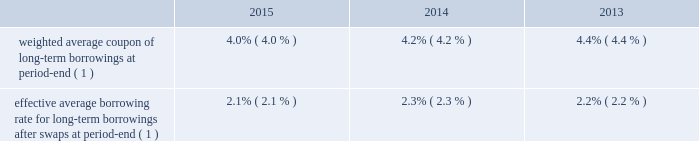Morgan stanley notes to consolidated financial statements 2014 ( continued ) senior debt securities often are denominated in various non-u.s .
Dollar currencies and may be structured to provide a return that is equity-linked , credit-linked , commodity-linked or linked to some other index ( e.g. , the consumer price index ) .
Senior debt also may be structured to be callable by the company or extendible at the option of holders of the senior debt securities .
Debt containing provisions that effectively allow the holders to put or extend the notes aggregated $ 2902 million at december 31 , 2015 and $ 2175 million at december 31 , 2014 .
In addition , in certain circumstances , certain purchasers may be entitled to cause the repurchase of the notes .
The aggregated value of notes subject to these arrangements was $ 650 million at december 31 , 2015 and $ 551 million at december 31 , 2014 .
Subordinated debt and junior subordinated debentures generally are issued to meet the capital requirements of the company or its regulated subsidiaries and primarily are u.s .
Dollar denominated .
During 2015 , morgan stanley capital trusts vi and vii redeemed all of their issued and outstanding 6.60% ( 6.60 % ) capital securities , respectively , and the company concurrently redeemed the related underlying junior subordinated debentures .
Senior debt 2014structured borrowings .
The company 2019s index-linked , equity-linked or credit-linked borrowings include various structured instruments whose payments and redemption values are linked to the performance of a specific index ( e.g. , standard & poor 2019s 500 ) , a basket of stocks , a specific equity security , a credit exposure or basket of credit exposures .
To minimize the exposure resulting from movements in the underlying index , equity , credit or other position , the company has entered into various swap contracts and purchased options that effectively convert the borrowing costs into floating rates based upon libor .
The company generally carries the entire structured borrowings at fair value .
The swaps and purchased options used to economically hedge the embedded features are derivatives and also are carried at fair value .
Changes in fair value related to the notes and economic hedges are reported in trading revenues .
See note 3 for further information on structured borrowings .
Subordinated debt and junior subordinated debentures .
Included in the long-term borrowings are subordinated notes of $ 10404 million having a contractual weighted average coupon of 4.45% ( 4.45 % ) at december 31 , 2015 and $ 8339 million having a contractual weighted average coupon of 4.57% ( 4.57 % ) at december 31 , 2014 .
Junior subordinated debentures outstanding by the company were $ 2870 million at december 31 , 2015 having a contractual weighted average coupon of 6.22% ( 6.22 % ) at december 31 , 2015 and $ 4868 million at december 31 , 2014 having a contractual weighted average coupon of 6.37% ( 6.37 % ) at december 31 , 2014 .
Maturities of the subordinated and junior subordinated notes range from 2022 to 2067 , while maturities of certain junior subordinated debentures can be extended to 2052 at the company 2019s option .
Asset and liability management .
In general , securities inventories that are not financed by secured funding sources and the majority of the company 2019s assets are financed with a combination of deposits , short-term funding , floating rate long-term debt or fixed rate long-term debt swapped to a floating rate .
Fixed assets are generally financed with fixed rate long-term debt .
The company uses interest rate swaps to more closely match these borrowings to the duration , holding period and interest rate characteristics of the assets being funded and to manage interest rate risk .
These swaps effectively convert certain of the company 2019s fixed rate borrowings into floating rate obligations .
In addition , for non-u.s .
Dollar currency borrowings that are not used to fund assets in the same currency , the company has entered into currency swaps that effectively convert the borrowings into u.s .
Dollar obligations .
The company 2019s use of swaps for asset and liability management affected its effective average borrowing rate .
Effective average borrowing rate. .

What is the difference in effective borrowing rate in 2014 due to the use of swaps? 
Computations: (4.2 - 2.3)
Answer: 1.9. 